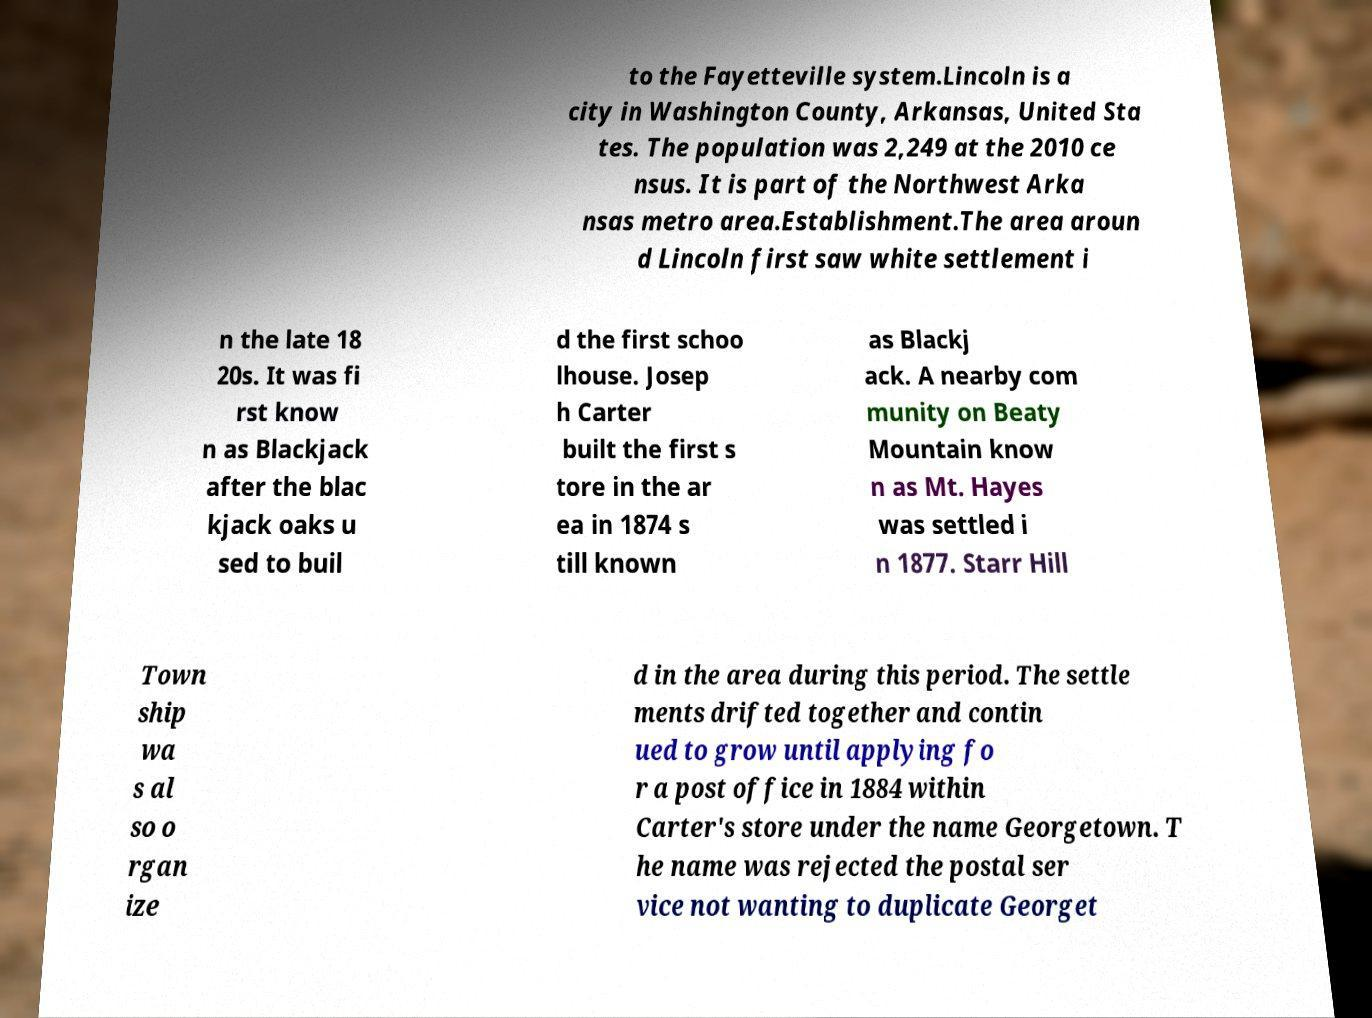I need the written content from this picture converted into text. Can you do that? to the Fayetteville system.Lincoln is a city in Washington County, Arkansas, United Sta tes. The population was 2,249 at the 2010 ce nsus. It is part of the Northwest Arka nsas metro area.Establishment.The area aroun d Lincoln first saw white settlement i n the late 18 20s. It was fi rst know n as Blackjack after the blac kjack oaks u sed to buil d the first schoo lhouse. Josep h Carter built the first s tore in the ar ea in 1874 s till known as Blackj ack. A nearby com munity on Beaty Mountain know n as Mt. Hayes was settled i n 1877. Starr Hill Town ship wa s al so o rgan ize d in the area during this period. The settle ments drifted together and contin ued to grow until applying fo r a post office in 1884 within Carter's store under the name Georgetown. T he name was rejected the postal ser vice not wanting to duplicate Georget 